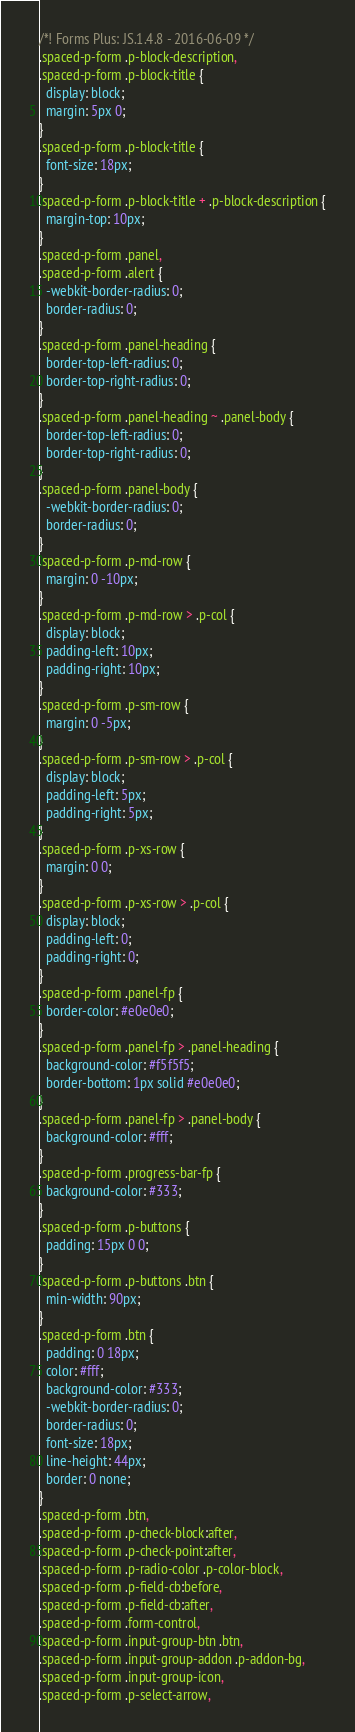<code> <loc_0><loc_0><loc_500><loc_500><_CSS_>/*! Forms Plus: JS.1.4.8 - 2016-06-09 */
.spaced-p-form .p-block-description,
.spaced-p-form .p-block-title {
  display: block;
  margin: 5px 0;
}
.spaced-p-form .p-block-title {
  font-size: 18px;
}
.spaced-p-form .p-block-title + .p-block-description {
  margin-top: 10px;
}
.spaced-p-form .panel,
.spaced-p-form .alert {
  -webkit-border-radius: 0;
  border-radius: 0;
}
.spaced-p-form .panel-heading {
  border-top-left-radius: 0;
  border-top-right-radius: 0;
}
.spaced-p-form .panel-heading ~ .panel-body {
  border-top-left-radius: 0;
  border-top-right-radius: 0;
}
.spaced-p-form .panel-body {
  -webkit-border-radius: 0;
  border-radius: 0;
}
.spaced-p-form .p-md-row {
  margin: 0 -10px;
}
.spaced-p-form .p-md-row > .p-col {
  display: block;
  padding-left: 10px;
  padding-right: 10px;
}
.spaced-p-form .p-sm-row {
  margin: 0 -5px;
}
.spaced-p-form .p-sm-row > .p-col {
  display: block;
  padding-left: 5px;
  padding-right: 5px;
}
.spaced-p-form .p-xs-row {
  margin: 0 0;
}
.spaced-p-form .p-xs-row > .p-col {
  display: block;
  padding-left: 0;
  padding-right: 0;
}
.spaced-p-form .panel-fp {
  border-color: #e0e0e0;
}
.spaced-p-form .panel-fp > .panel-heading {
  background-color: #f5f5f5;
  border-bottom: 1px solid #e0e0e0;
}
.spaced-p-form .panel-fp > .panel-body {
  background-color: #fff;
}
.spaced-p-form .progress-bar-fp {
  background-color: #333;
}
.spaced-p-form .p-buttons {
  padding: 15px 0 0;
}
.spaced-p-form .p-buttons .btn {
  min-width: 90px;
}
.spaced-p-form .btn {
  padding: 0 18px;
  color: #fff;
  background-color: #333;
  -webkit-border-radius: 0;
  border-radius: 0;
  font-size: 18px;
  line-height: 44px;
  border: 0 none;
}
.spaced-p-form .btn,
.spaced-p-form .p-check-block:after,
.spaced-p-form .p-check-point:after,
.spaced-p-form .p-radio-color .p-color-block,
.spaced-p-form .p-field-cb:before,
.spaced-p-form .p-field-cb:after,
.spaced-p-form .form-control,
.spaced-p-form .input-group-btn .btn,
.spaced-p-form .input-group-addon .p-addon-bg,
.spaced-p-form .input-group-icon,
.spaced-p-form .p-select-arrow,</code> 